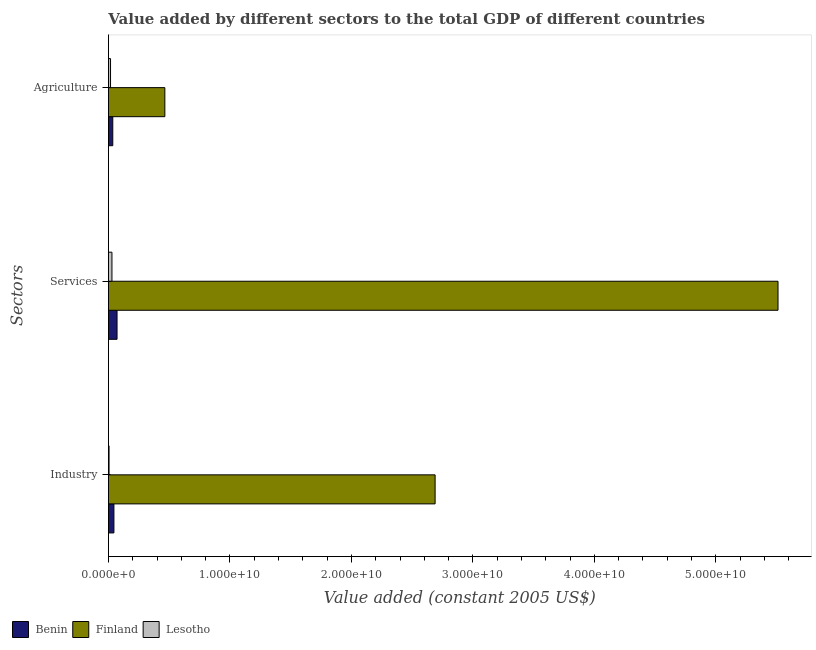How many different coloured bars are there?
Keep it short and to the point. 3. How many groups of bars are there?
Keep it short and to the point. 3. How many bars are there on the 2nd tick from the top?
Offer a terse response. 3. How many bars are there on the 2nd tick from the bottom?
Your answer should be very brief. 3. What is the label of the 2nd group of bars from the top?
Provide a succinct answer. Services. What is the value added by services in Lesotho?
Your response must be concise. 2.90e+08. Across all countries, what is the maximum value added by services?
Provide a succinct answer. 5.51e+1. Across all countries, what is the minimum value added by services?
Your response must be concise. 2.90e+08. In which country was the value added by services minimum?
Ensure brevity in your answer.  Lesotho. What is the total value added by services in the graph?
Keep it short and to the point. 5.61e+1. What is the difference between the value added by agricultural sector in Finland and that in Lesotho?
Keep it short and to the point. 4.47e+09. What is the difference between the value added by industrial sector in Finland and the value added by services in Benin?
Keep it short and to the point. 2.62e+1. What is the average value added by agricultural sector per country?
Offer a very short reply. 1.72e+09. What is the difference between the value added by agricultural sector and value added by industrial sector in Benin?
Offer a terse response. -9.39e+07. In how many countries, is the value added by industrial sector greater than 40000000000 US$?
Your answer should be very brief. 0. What is the ratio of the value added by industrial sector in Lesotho to that in Benin?
Your answer should be compact. 0.12. Is the value added by industrial sector in Benin less than that in Lesotho?
Give a very brief answer. No. What is the difference between the highest and the second highest value added by services?
Give a very brief answer. 5.44e+1. What is the difference between the highest and the lowest value added by services?
Ensure brevity in your answer.  5.48e+1. Is the sum of the value added by industrial sector in Lesotho and Finland greater than the maximum value added by services across all countries?
Keep it short and to the point. No. What does the 1st bar from the top in Services represents?
Keep it short and to the point. Lesotho. What does the 3rd bar from the bottom in Agriculture represents?
Make the answer very short. Lesotho. How many bars are there?
Give a very brief answer. 9. How many countries are there in the graph?
Offer a terse response. 3. Are the values on the major ticks of X-axis written in scientific E-notation?
Offer a terse response. Yes. Does the graph contain grids?
Offer a very short reply. No. How are the legend labels stacked?
Offer a terse response. Horizontal. What is the title of the graph?
Your answer should be compact. Value added by different sectors to the total GDP of different countries. Does "Netherlands" appear as one of the legend labels in the graph?
Keep it short and to the point. No. What is the label or title of the X-axis?
Give a very brief answer. Value added (constant 2005 US$). What is the label or title of the Y-axis?
Your answer should be very brief. Sectors. What is the Value added (constant 2005 US$) in Benin in Industry?
Your answer should be very brief. 4.52e+08. What is the Value added (constant 2005 US$) in Finland in Industry?
Offer a very short reply. 2.69e+1. What is the Value added (constant 2005 US$) of Lesotho in Industry?
Keep it short and to the point. 5.26e+07. What is the Value added (constant 2005 US$) in Benin in Services?
Provide a succinct answer. 7.09e+08. What is the Value added (constant 2005 US$) in Finland in Services?
Make the answer very short. 5.51e+1. What is the Value added (constant 2005 US$) of Lesotho in Services?
Offer a very short reply. 2.90e+08. What is the Value added (constant 2005 US$) of Benin in Agriculture?
Offer a very short reply. 3.58e+08. What is the Value added (constant 2005 US$) in Finland in Agriculture?
Provide a short and direct response. 4.64e+09. What is the Value added (constant 2005 US$) of Lesotho in Agriculture?
Provide a succinct answer. 1.73e+08. Across all Sectors, what is the maximum Value added (constant 2005 US$) in Benin?
Provide a short and direct response. 7.09e+08. Across all Sectors, what is the maximum Value added (constant 2005 US$) of Finland?
Give a very brief answer. 5.51e+1. Across all Sectors, what is the maximum Value added (constant 2005 US$) in Lesotho?
Provide a short and direct response. 2.90e+08. Across all Sectors, what is the minimum Value added (constant 2005 US$) of Benin?
Offer a terse response. 3.58e+08. Across all Sectors, what is the minimum Value added (constant 2005 US$) in Finland?
Your response must be concise. 4.64e+09. Across all Sectors, what is the minimum Value added (constant 2005 US$) of Lesotho?
Keep it short and to the point. 5.26e+07. What is the total Value added (constant 2005 US$) in Benin in the graph?
Give a very brief answer. 1.52e+09. What is the total Value added (constant 2005 US$) in Finland in the graph?
Keep it short and to the point. 8.67e+1. What is the total Value added (constant 2005 US$) of Lesotho in the graph?
Offer a very short reply. 5.16e+08. What is the difference between the Value added (constant 2005 US$) of Benin in Industry and that in Services?
Offer a terse response. -2.58e+08. What is the difference between the Value added (constant 2005 US$) of Finland in Industry and that in Services?
Keep it short and to the point. -2.82e+1. What is the difference between the Value added (constant 2005 US$) of Lesotho in Industry and that in Services?
Make the answer very short. -2.38e+08. What is the difference between the Value added (constant 2005 US$) of Benin in Industry and that in Agriculture?
Keep it short and to the point. 9.39e+07. What is the difference between the Value added (constant 2005 US$) in Finland in Industry and that in Agriculture?
Offer a terse response. 2.22e+1. What is the difference between the Value added (constant 2005 US$) in Lesotho in Industry and that in Agriculture?
Give a very brief answer. -1.20e+08. What is the difference between the Value added (constant 2005 US$) in Benin in Services and that in Agriculture?
Offer a very short reply. 3.51e+08. What is the difference between the Value added (constant 2005 US$) of Finland in Services and that in Agriculture?
Your response must be concise. 5.05e+1. What is the difference between the Value added (constant 2005 US$) in Lesotho in Services and that in Agriculture?
Give a very brief answer. 1.17e+08. What is the difference between the Value added (constant 2005 US$) of Benin in Industry and the Value added (constant 2005 US$) of Finland in Services?
Provide a short and direct response. -5.47e+1. What is the difference between the Value added (constant 2005 US$) in Benin in Industry and the Value added (constant 2005 US$) in Lesotho in Services?
Keep it short and to the point. 1.61e+08. What is the difference between the Value added (constant 2005 US$) in Finland in Industry and the Value added (constant 2005 US$) in Lesotho in Services?
Your answer should be compact. 2.66e+1. What is the difference between the Value added (constant 2005 US$) of Benin in Industry and the Value added (constant 2005 US$) of Finland in Agriculture?
Give a very brief answer. -4.19e+09. What is the difference between the Value added (constant 2005 US$) in Benin in Industry and the Value added (constant 2005 US$) in Lesotho in Agriculture?
Give a very brief answer. 2.79e+08. What is the difference between the Value added (constant 2005 US$) of Finland in Industry and the Value added (constant 2005 US$) of Lesotho in Agriculture?
Provide a short and direct response. 2.67e+1. What is the difference between the Value added (constant 2005 US$) of Benin in Services and the Value added (constant 2005 US$) of Finland in Agriculture?
Ensure brevity in your answer.  -3.93e+09. What is the difference between the Value added (constant 2005 US$) in Benin in Services and the Value added (constant 2005 US$) in Lesotho in Agriculture?
Provide a succinct answer. 5.36e+08. What is the difference between the Value added (constant 2005 US$) in Finland in Services and the Value added (constant 2005 US$) in Lesotho in Agriculture?
Your response must be concise. 5.49e+1. What is the average Value added (constant 2005 US$) of Benin per Sectors?
Offer a very short reply. 5.06e+08. What is the average Value added (constant 2005 US$) of Finland per Sectors?
Your response must be concise. 2.89e+1. What is the average Value added (constant 2005 US$) in Lesotho per Sectors?
Your answer should be compact. 1.72e+08. What is the difference between the Value added (constant 2005 US$) in Benin and Value added (constant 2005 US$) in Finland in Industry?
Ensure brevity in your answer.  -2.64e+1. What is the difference between the Value added (constant 2005 US$) of Benin and Value added (constant 2005 US$) of Lesotho in Industry?
Provide a succinct answer. 3.99e+08. What is the difference between the Value added (constant 2005 US$) in Finland and Value added (constant 2005 US$) in Lesotho in Industry?
Your answer should be very brief. 2.68e+1. What is the difference between the Value added (constant 2005 US$) of Benin and Value added (constant 2005 US$) of Finland in Services?
Provide a succinct answer. -5.44e+1. What is the difference between the Value added (constant 2005 US$) of Benin and Value added (constant 2005 US$) of Lesotho in Services?
Your answer should be compact. 4.19e+08. What is the difference between the Value added (constant 2005 US$) of Finland and Value added (constant 2005 US$) of Lesotho in Services?
Ensure brevity in your answer.  5.48e+1. What is the difference between the Value added (constant 2005 US$) in Benin and Value added (constant 2005 US$) in Finland in Agriculture?
Your response must be concise. -4.29e+09. What is the difference between the Value added (constant 2005 US$) of Benin and Value added (constant 2005 US$) of Lesotho in Agriculture?
Give a very brief answer. 1.85e+08. What is the difference between the Value added (constant 2005 US$) of Finland and Value added (constant 2005 US$) of Lesotho in Agriculture?
Ensure brevity in your answer.  4.47e+09. What is the ratio of the Value added (constant 2005 US$) of Benin in Industry to that in Services?
Keep it short and to the point. 0.64. What is the ratio of the Value added (constant 2005 US$) of Finland in Industry to that in Services?
Keep it short and to the point. 0.49. What is the ratio of the Value added (constant 2005 US$) of Lesotho in Industry to that in Services?
Keep it short and to the point. 0.18. What is the ratio of the Value added (constant 2005 US$) of Benin in Industry to that in Agriculture?
Offer a very short reply. 1.26. What is the ratio of the Value added (constant 2005 US$) of Finland in Industry to that in Agriculture?
Offer a very short reply. 5.79. What is the ratio of the Value added (constant 2005 US$) of Lesotho in Industry to that in Agriculture?
Ensure brevity in your answer.  0.3. What is the ratio of the Value added (constant 2005 US$) of Benin in Services to that in Agriculture?
Keep it short and to the point. 1.98. What is the ratio of the Value added (constant 2005 US$) in Finland in Services to that in Agriculture?
Provide a succinct answer. 11.87. What is the ratio of the Value added (constant 2005 US$) of Lesotho in Services to that in Agriculture?
Make the answer very short. 1.68. What is the difference between the highest and the second highest Value added (constant 2005 US$) in Benin?
Offer a very short reply. 2.58e+08. What is the difference between the highest and the second highest Value added (constant 2005 US$) in Finland?
Your answer should be compact. 2.82e+1. What is the difference between the highest and the second highest Value added (constant 2005 US$) of Lesotho?
Keep it short and to the point. 1.17e+08. What is the difference between the highest and the lowest Value added (constant 2005 US$) of Benin?
Ensure brevity in your answer.  3.51e+08. What is the difference between the highest and the lowest Value added (constant 2005 US$) in Finland?
Your response must be concise. 5.05e+1. What is the difference between the highest and the lowest Value added (constant 2005 US$) in Lesotho?
Give a very brief answer. 2.38e+08. 